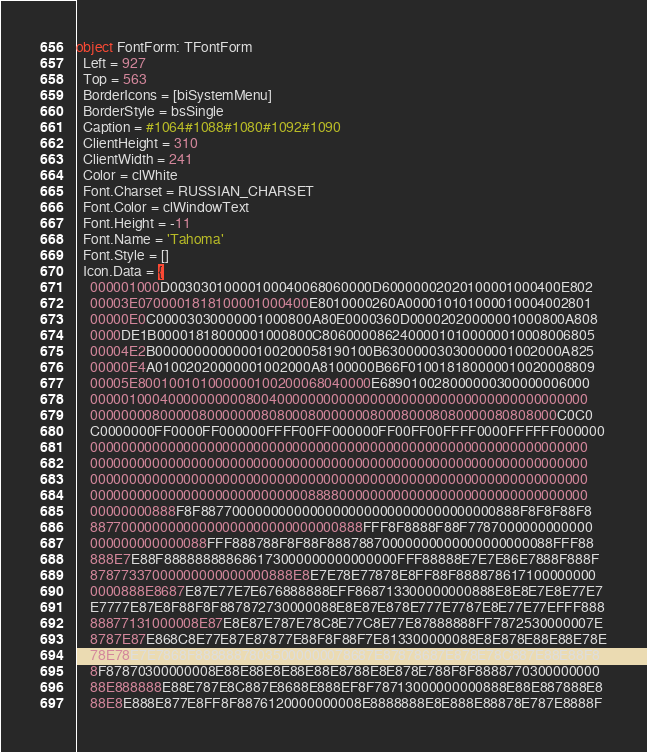<code> <loc_0><loc_0><loc_500><loc_500><_Pascal_>object FontForm: TFontForm
  Left = 927
  Top = 563
  BorderIcons = [biSystemMenu]
  BorderStyle = bsSingle
  Caption = #1064#1088#1080#1092#1090
  ClientHeight = 310
  ClientWidth = 241
  Color = clWhite
  Font.Charset = RUSSIAN_CHARSET
  Font.Color = clWindowText
  Font.Height = -11
  Font.Name = 'Tahoma'
  Font.Style = []
  Icon.Data = {
    000001000D00303010000100040068060000D60000002020100001000400E802
    00003E0700001818100001000400E8010000260A000010101000010004002801
    00000E0C00003030000001000800A80E0000360D00002020000001000800A808
    0000DE1B00001818000001000800C80600008624000010100000010008006805
    00004E2B0000000000000100200058190100B63000003030000001002000A825
    00000E4A01002020000001002000A8100000B66F010018180000010020008809
    00005E800100101000000100200068040000E689010028000000300000006000
    0000010004000000000080040000000000000000000000000000000000000000
    000000008000008000000080800080000000800080008080000080808000C0C0
    C0000000FF0000FF000000FFFF00FF000000FF00FF00FFFF0000FFFFFF000000
    0000000000000000000000000000000000000000000000000000000000000000
    0000000000000000000000000000000000000000000000000000000000000000
    0000000000000000000000000000000000000000000000000000000000000000
    0000000000000000000000000000888800000000000000000000000000000000
    00000000888F8F88770000000000000000000000000000000000888F8F8F88F8
    88770000000000000000000000000000888FFF8F8888F88F7787000000000000
    000000000000088FFF888788F8F88F88878870000000000000000000088FFF88
    888E7E88F888888888686173000000000000000FFF88888E7E7E86E7888F888F
    87877337000000000000000888E8E7E78E77878E8FF88F888878617100000000
    0000888E8687E87E77E7E676888888EFF868713300000000888E8E8E7E8E77E7
    E7777E87E8F88F8F887872730000088E8E87E878E777E7787E8E77E77EFFF888
    88877131000008E87E8E87E787E78C8E77C8E77E87888888FF7872530000007E
    8787E87E868C8E77E87E87877E88F8F88F7E813300000088E8E878E88E88E78E
    78E78E7E7868F88888878035000000078687E87878687E878E78C887E88E88F8
    8F87870300000008E88E88E8E88E88E8788E8E878E788F8F8888770300000000
    88E888888E88E787E8C887E8688E888EF8F78713000000000888E88E887888E8
    88E8E888E877E8FF8F8876120000000008E8888888E8E888E88878E787E8888F</code> 